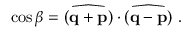Convert formula to latex. <formula><loc_0><loc_0><loc_500><loc_500>\cos \beta = \widehat { ( { q } + { p } ) } \cdot \widehat { ( { q } - { p } ) } \ .</formula> 